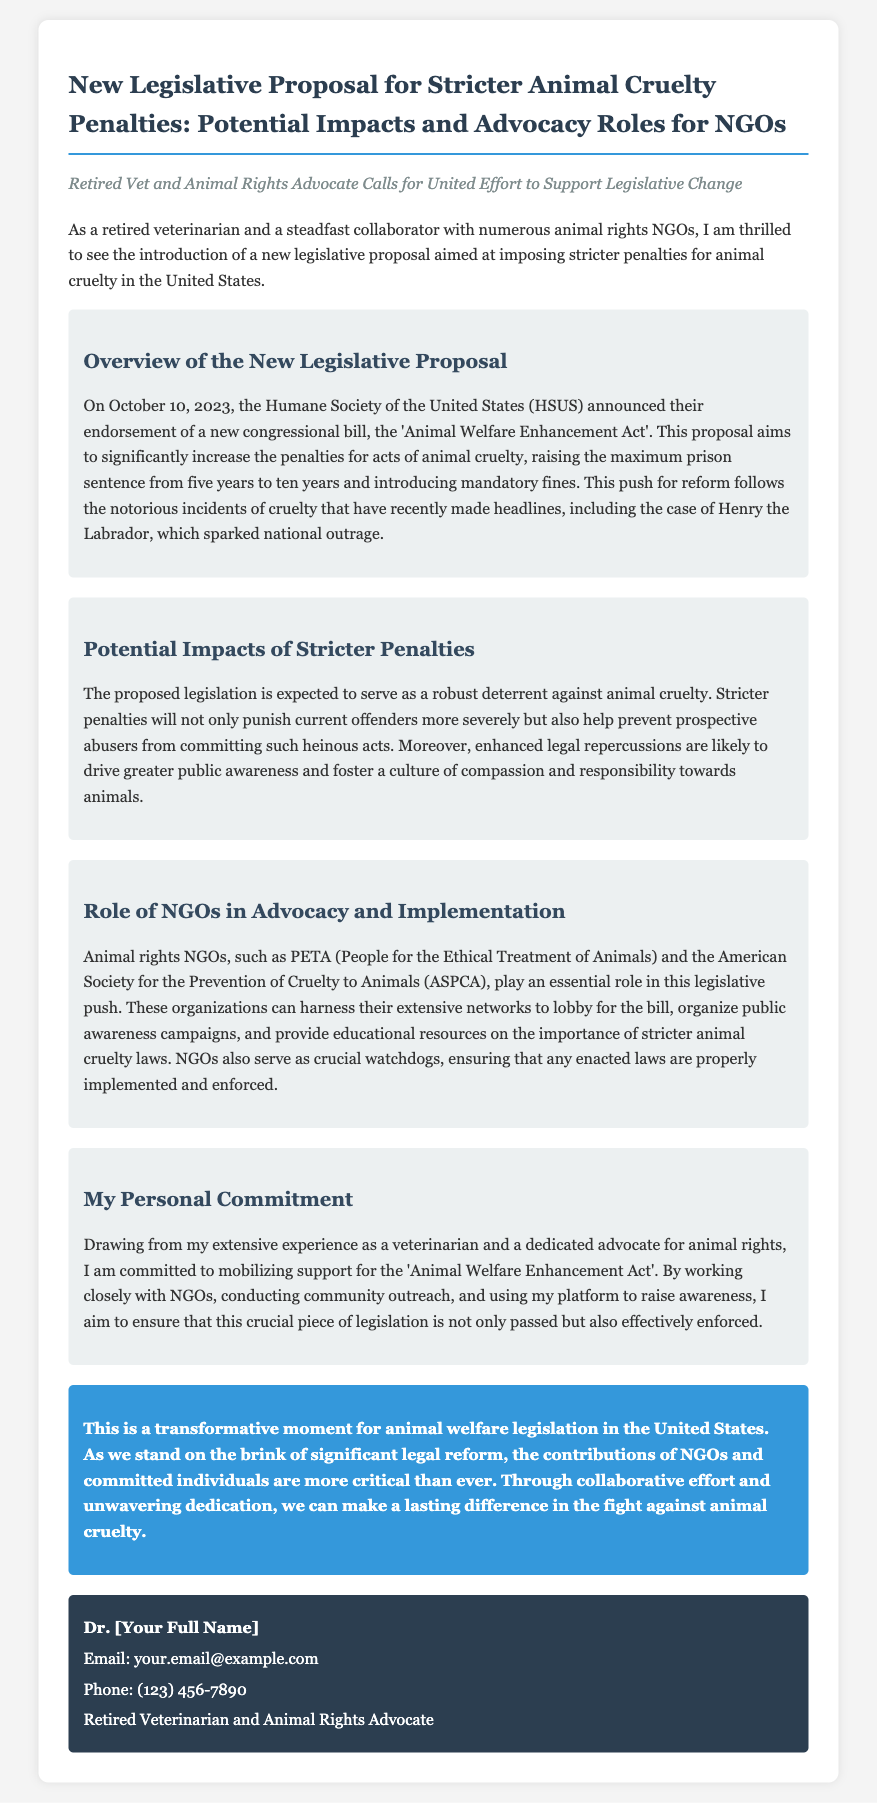What is the date the legislative proposal was announced? The date of the announcement regarding the legislative proposal is provided in the document as October 10, 2023.
Answer: October 10, 2023 What is the title of the new congressional bill? The title of the congressional bill is mentioned in the document as the 'Animal Welfare Enhancement Act'.
Answer: Animal Welfare Enhancement Act What is the maximum prison sentence under the new proposal? The proposed legislation aims to raise the maximum prison sentence for animal cruelty, specifically noted in the document as ten years.
Answer: ten years Which organization endorsed the legislation? The document specifies that the Humane Society of the United States (HSUS) is the organization that endorsed the new congressional bill.
Answer: Humane Society of the United States (HSUS) What role do NGOs play in this legislative push? The document outlines that NGOs are expected to lobby for the bill, organize campaigns, and provide educational resources on animal cruelty laws.
Answer: Lobby for the bill, organize campaigns, provide educational resources What is the expected outcome of the proposed legislation? The expected outcome described in the document is to serve as a robust deterrent against animal cruelty and to foster a culture of compassion and responsibility.
Answer: A robust deterrent against animal cruelty What is the author's personal commitment regarding the legislative proposal? The author expresses a commitment to mobilizing support for the 'Animal Welfare Enhancement Act' and ensuring its enforcement through various means.
Answer: Mobilizing support for the 'Animal Welfare Enhancement Act' Why is this moment described as transformative? The document characterizes this moment as transformative due to the significant legal reform being pursued for animal welfare in the United States.
Answer: Significant legal reform for animal welfare 